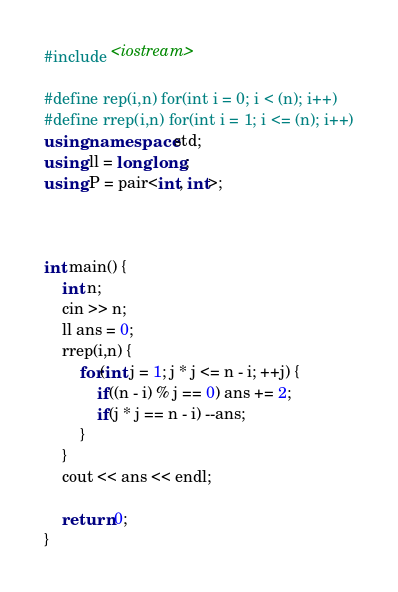Convert code to text. <code><loc_0><loc_0><loc_500><loc_500><_C++_>#include <iostream>

#define rep(i,n) for(int i = 0; i < (n); i++)
#define rrep(i,n) for(int i = 1; i <= (n); i++)
using namespace std;
using ll = long long;
using P = pair<int, int>;



int main() {
    int n;
    cin >> n;
    ll ans = 0;
    rrep(i,n) {
        for(int j = 1; j * j <= n - i; ++j) {
            if((n - i) % j == 0) ans += 2;
            if(j * j == n - i) --ans;
        }
    }
    cout << ans << endl;

    return 0;
}
</code> 